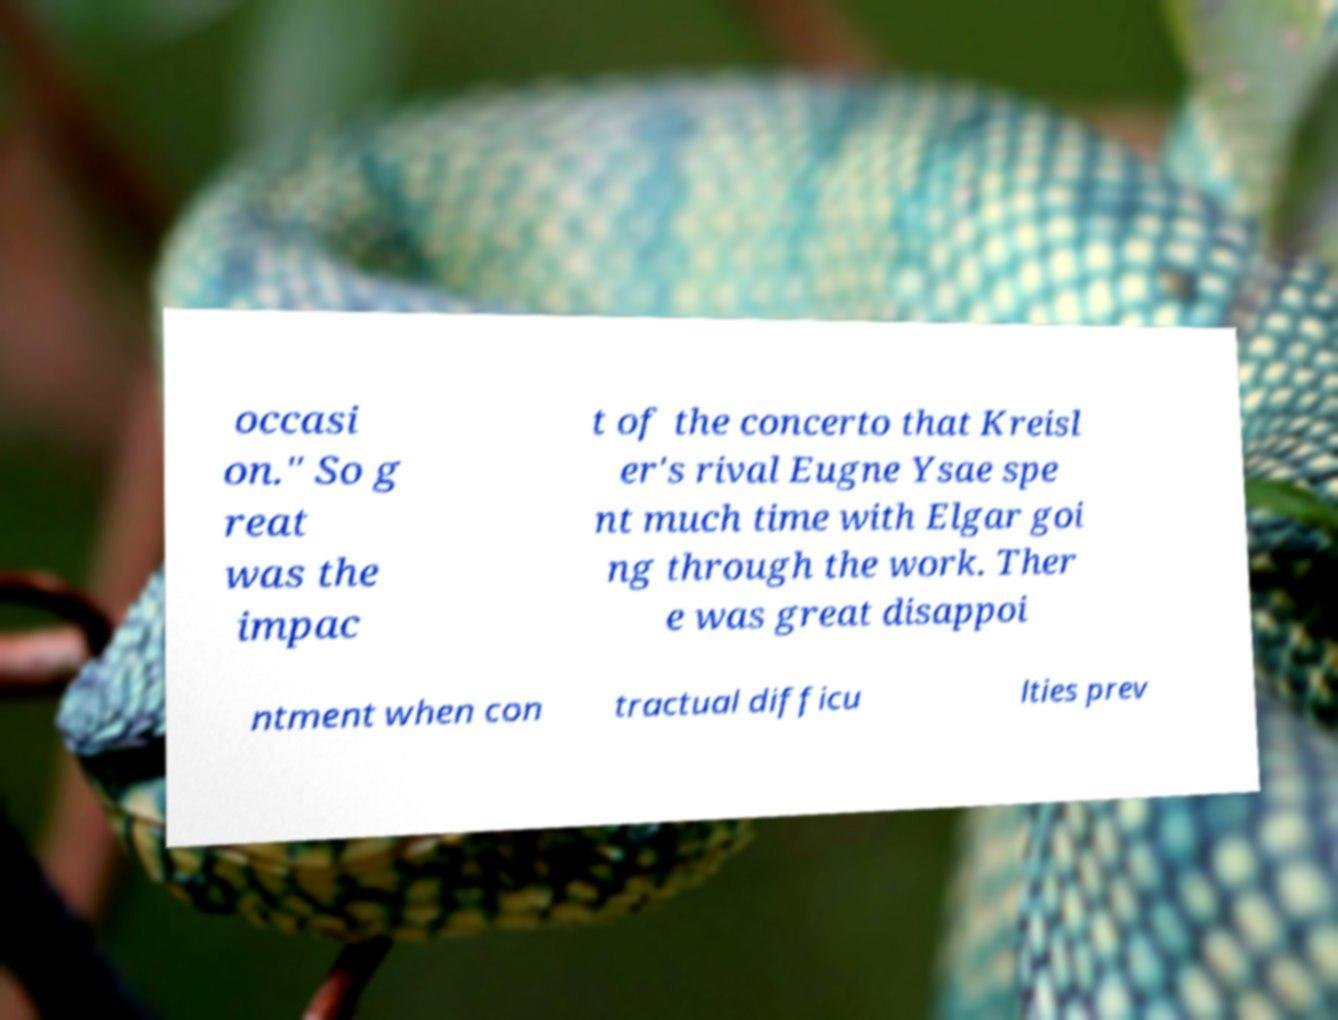Can you accurately transcribe the text from the provided image for me? occasi on." So g reat was the impac t of the concerto that Kreisl er's rival Eugne Ysae spe nt much time with Elgar goi ng through the work. Ther e was great disappoi ntment when con tractual difficu lties prev 